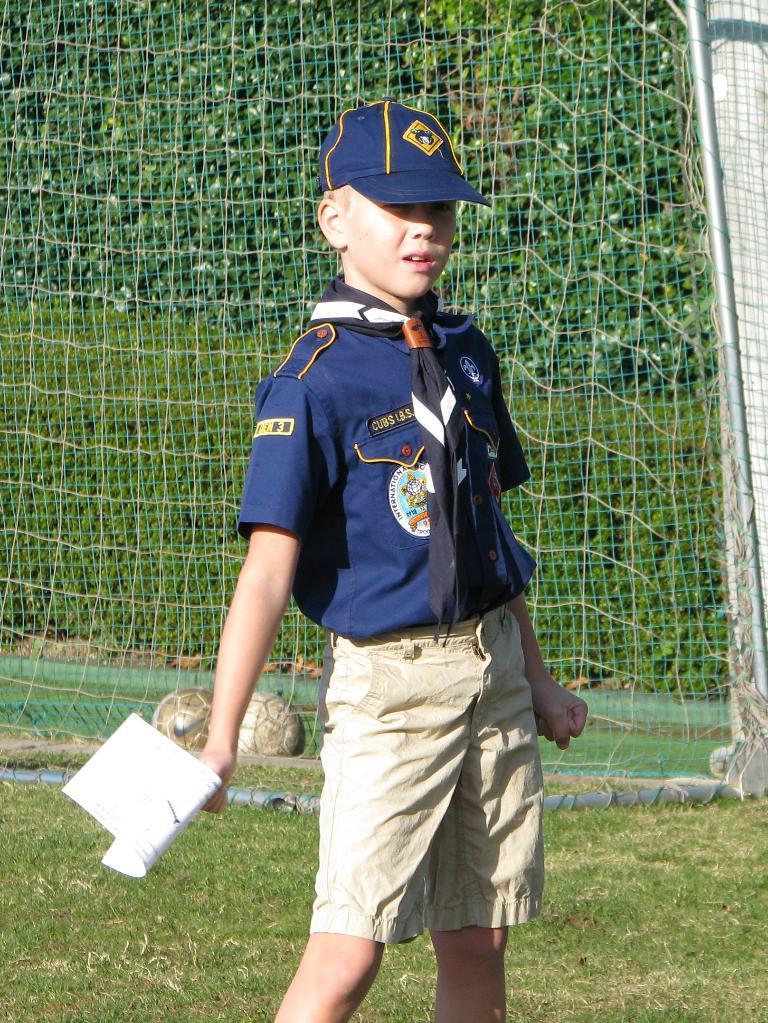In one or two sentences, can you explain what this image depicts? In this image I can see a person standing and holding a paper. He is wearing a blue and cream color dress and the blue cap. Back I can see few trees and net. 